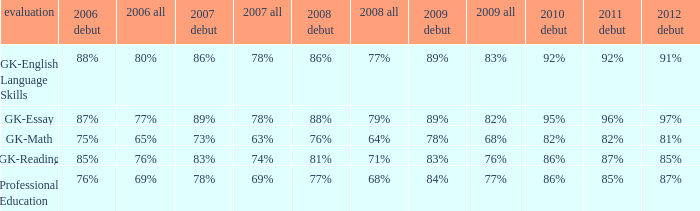What is the percentage for all in 2008 when all in 2007 was 69%? 68%. 